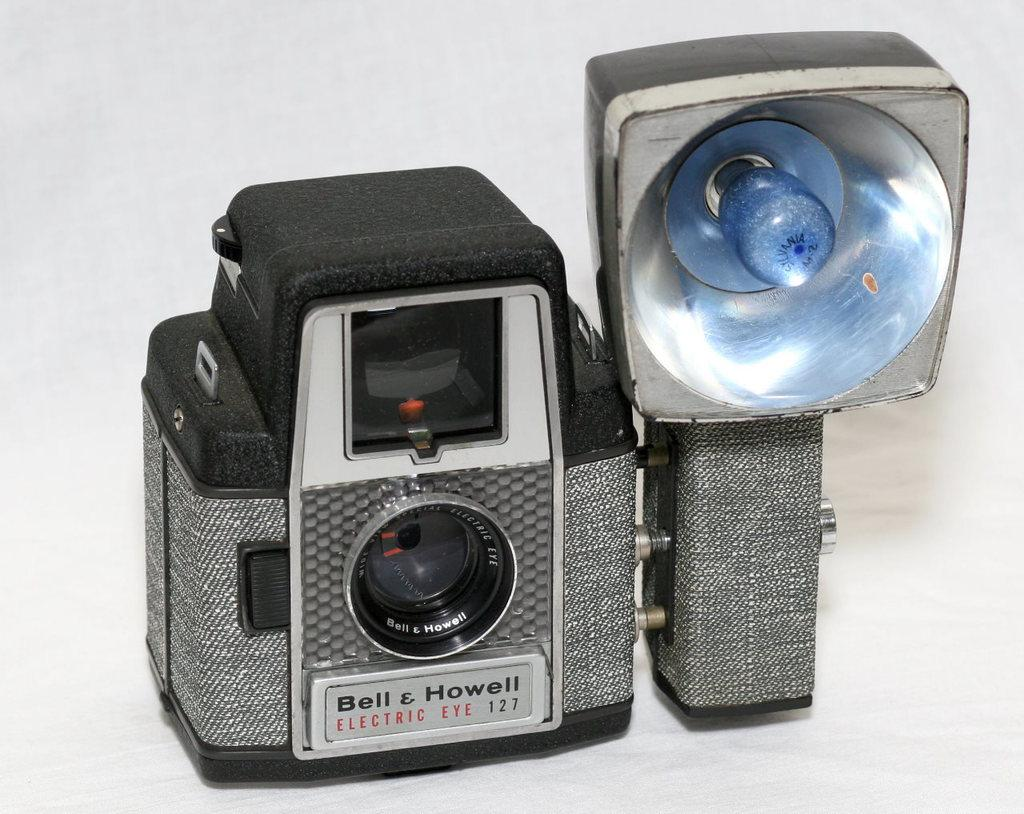<image>
Relay a brief, clear account of the picture shown. A Bell & Howell camera with flash mount 